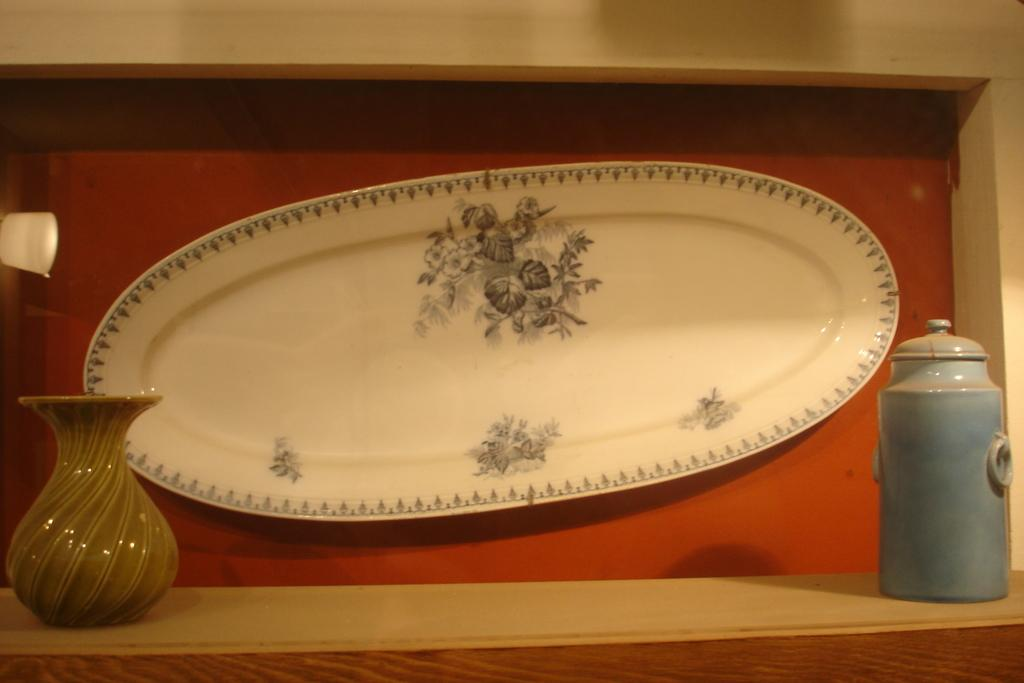What type of container is present in the image? There is a vase and a jar in the image. Where are the vase and jar located? The vase and jar are on a wooden platform. What other object can be seen in the image? There is a plate in the image. What is the color of the surface the plate is on? The plate is on a red surface. What can be seen on the left side of the image? There is a white object on the left side of the image. What type of songs can be heard coming from the vase in the image? There are no songs present in the image, as the vase is an inanimate object and cannot produce sound. 